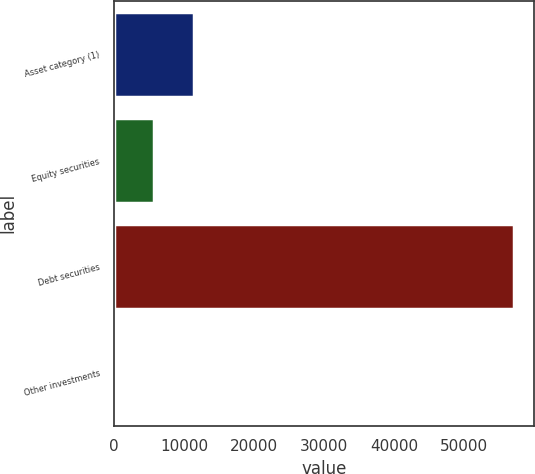Convert chart to OTSL. <chart><loc_0><loc_0><loc_500><loc_500><bar_chart><fcel>Asset category (1)<fcel>Equity securities<fcel>Debt securities<fcel>Other investments<nl><fcel>11423.2<fcel>5713.6<fcel>57100<fcel>4<nl></chart> 